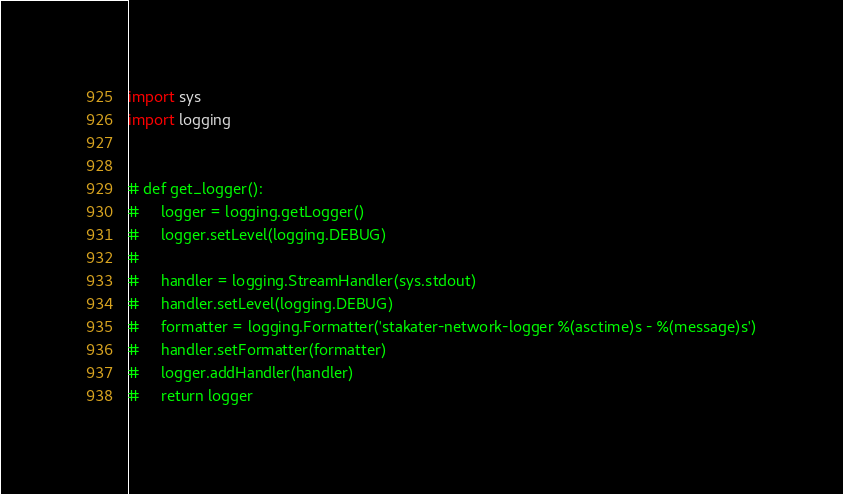<code> <loc_0><loc_0><loc_500><loc_500><_Python_>
import sys
import logging


# def get_logger():
#     logger = logging.getLogger()
#     logger.setLevel(logging.DEBUG)
#
#     handler = logging.StreamHandler(sys.stdout)
#     handler.setLevel(logging.DEBUG)
#     formatter = logging.Formatter('stakater-network-logger %(asctime)s - %(message)s')
#     handler.setFormatter(formatter)
#     logger.addHandler(handler)
#     return logger
</code> 